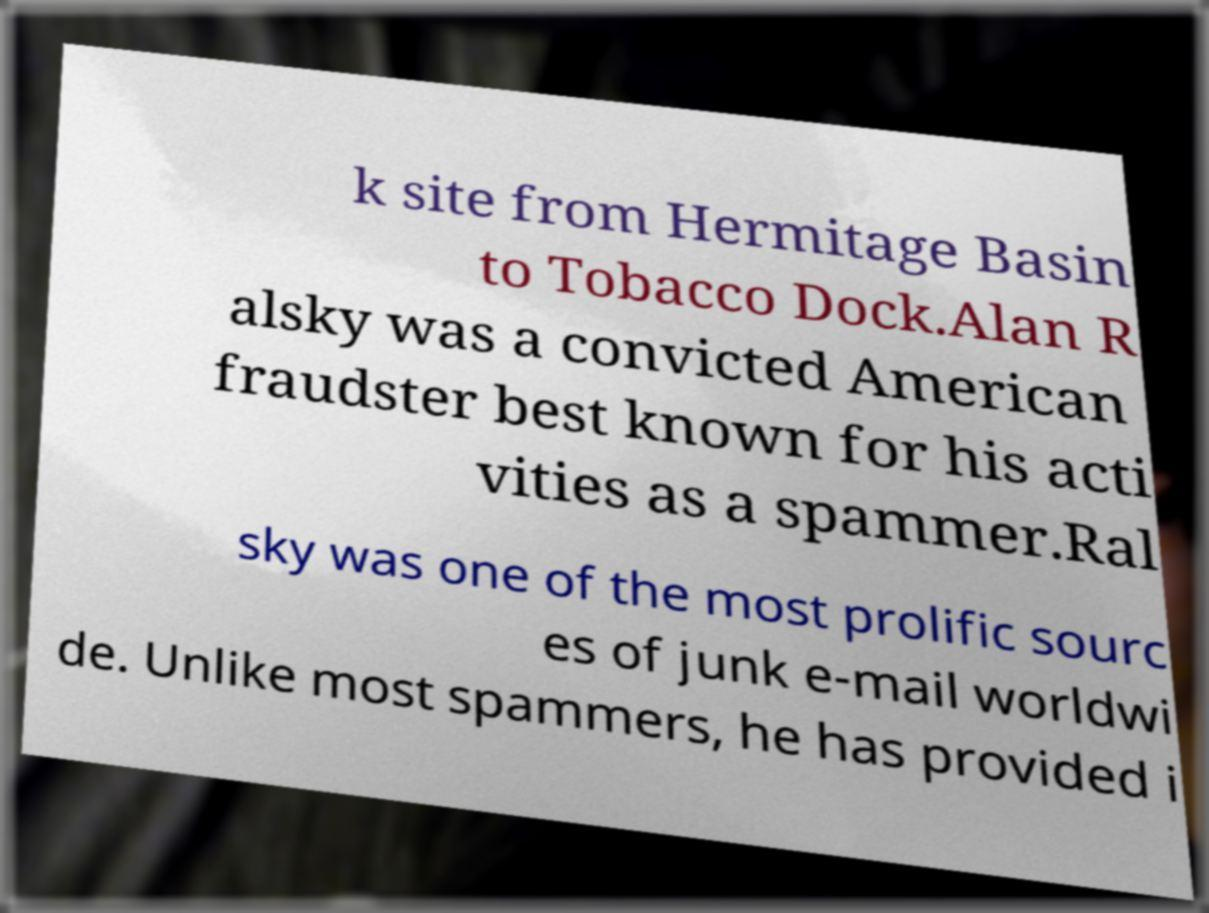Could you assist in decoding the text presented in this image and type it out clearly? k site from Hermitage Basin to Tobacco Dock.Alan R alsky was a convicted American fraudster best known for his acti vities as a spammer.Ral sky was one of the most prolific sourc es of junk e-mail worldwi de. Unlike most spammers, he has provided i 